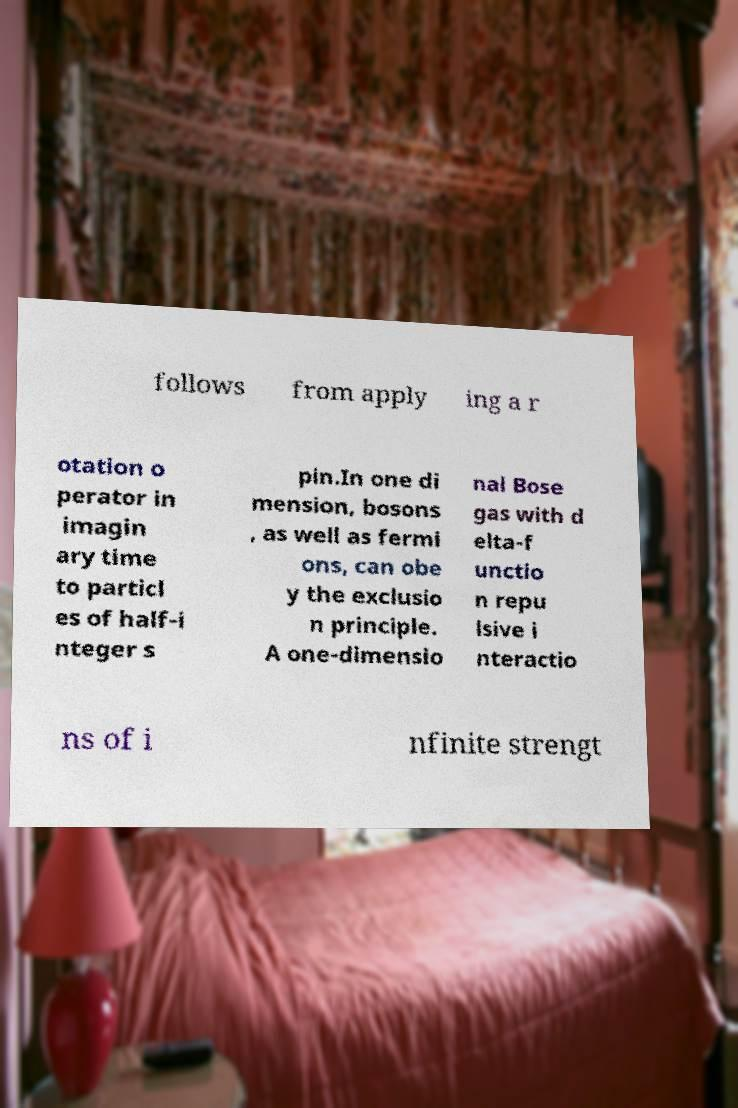For documentation purposes, I need the text within this image transcribed. Could you provide that? follows from apply ing a r otation o perator in imagin ary time to particl es of half-i nteger s pin.In one di mension, bosons , as well as fermi ons, can obe y the exclusio n principle. A one-dimensio nal Bose gas with d elta-f unctio n repu lsive i nteractio ns of i nfinite strengt 